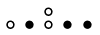Convert formula to latex. <formula><loc_0><loc_0><loc_500><loc_500>\begin{smallmatrix} & & \circ \\ \circ & \bullet & \circ & \bullet & \bullet & \\ \end{smallmatrix}</formula> 